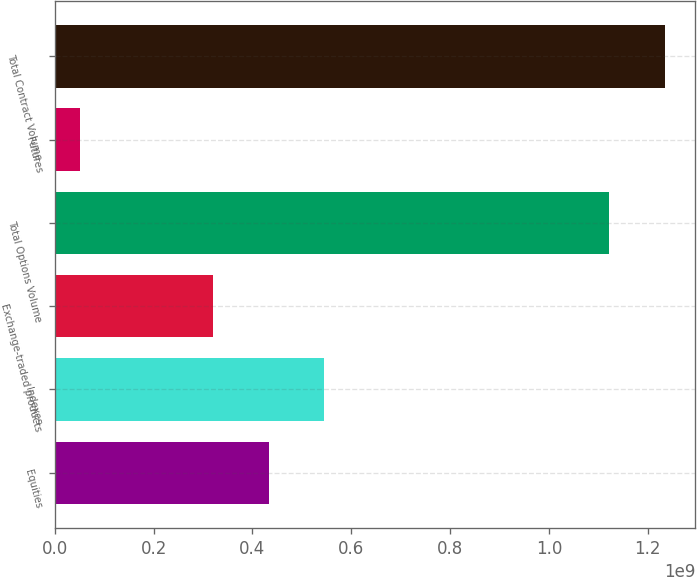<chart> <loc_0><loc_0><loc_500><loc_500><bar_chart><fcel>Equities<fcel>Indexes<fcel>Exchange-traded products<fcel>Total Options Volume<fcel>Futures<fcel>Total Contract Volume<nl><fcel>4.33223e+08<fcel>5.45449e+08<fcel>3.20997e+08<fcel>1.12226e+09<fcel>5.16712e+07<fcel>1.23449e+09<nl></chart> 